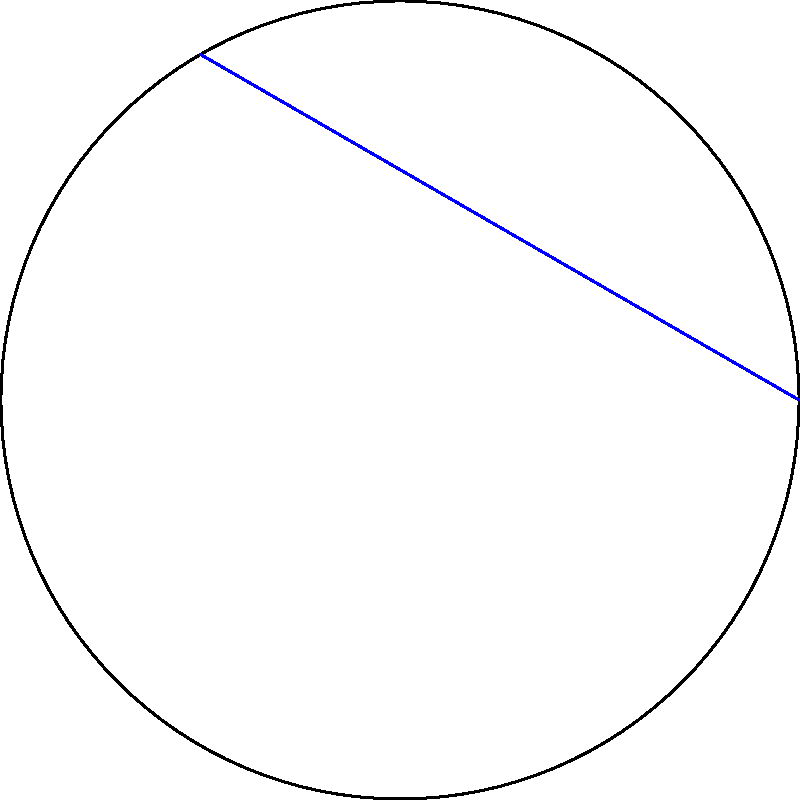On a curved trading floor represented as a non-Euclidean surface (shown as a circle), what is the shortest path between two currency traders at points A and B? Consider the implications for efficient communication during fast-paced market movements. To solve this problem, we need to understand the principles of non-Euclidean geometry on a curved surface:

1. In Euclidean geometry, the shortest path between two points is a straight line. However, on a curved surface, this is not always true.

2. On a spherical surface (which our circular trading floor represents in 2D), the shortest path between two points is along a great circle, which is the intersection of the sphere with a plane passing through the center of the sphere and the two points.

3. In our 2D representation, this great circle path appears as an arc of the circle.

4. The blue line represents the Euclidean straight path, while the red arc represents the non-Euclidean shortest path on the curved surface.

5. Although the arc looks longer in the 2D representation, it is actually the shortest path on the curved surface.

6. In the context of a trading floor, this means that for efficient communication during fast-paced market movements, traders should follow the curved path (red arc) rather than trying to move in a straight line (blue line).

7. This concept is crucial in understanding how information and physical movement would propagate most efficiently on a non-Euclidean trading floor, potentially impacting the speed of transactions and information flow during critical market events.
Answer: The arc along the circle's circumference (great circle path) 